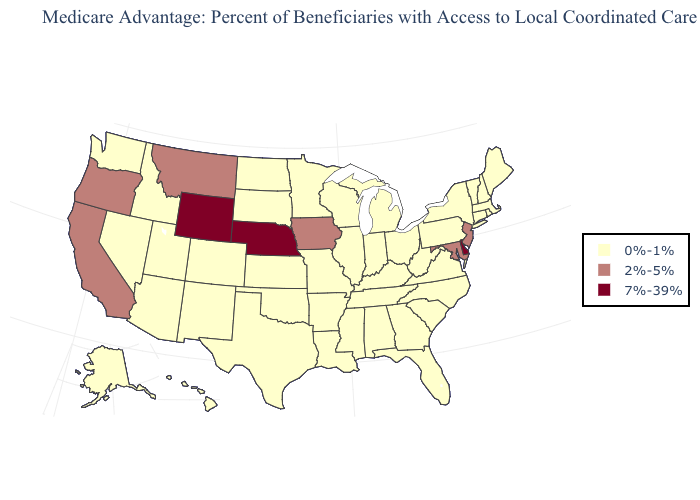What is the highest value in the USA?
Short answer required. 7%-39%. What is the value of Kansas?
Write a very short answer. 0%-1%. What is the lowest value in states that border Connecticut?
Answer briefly. 0%-1%. Does Pennsylvania have the highest value in the Northeast?
Be succinct. No. Does the first symbol in the legend represent the smallest category?
Give a very brief answer. Yes. What is the lowest value in the West?
Be succinct. 0%-1%. Name the states that have a value in the range 7%-39%?
Short answer required. Delaware, Nebraska, Wyoming. Among the states that border North Dakota , which have the lowest value?
Quick response, please. Minnesota, South Dakota. Does New Jersey have the highest value in the USA?
Short answer required. No. Does Alabama have the highest value in the USA?
Keep it brief. No. Among the states that border Massachusetts , which have the highest value?
Be succinct. Connecticut, New Hampshire, New York, Rhode Island, Vermont. Name the states that have a value in the range 7%-39%?
Short answer required. Delaware, Nebraska, Wyoming. What is the value of Tennessee?
Answer briefly. 0%-1%. What is the value of California?
Keep it brief. 2%-5%. What is the value of Kansas?
Be succinct. 0%-1%. 